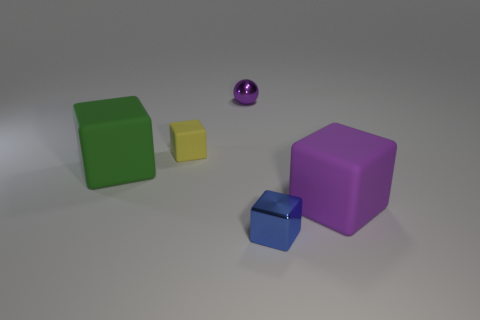What material is the purple block? The purple block appears to have a matte finish and a solid, uniform color, suggesting it could be made of a dense, non-reflective material such as rubber or dense plastic. 